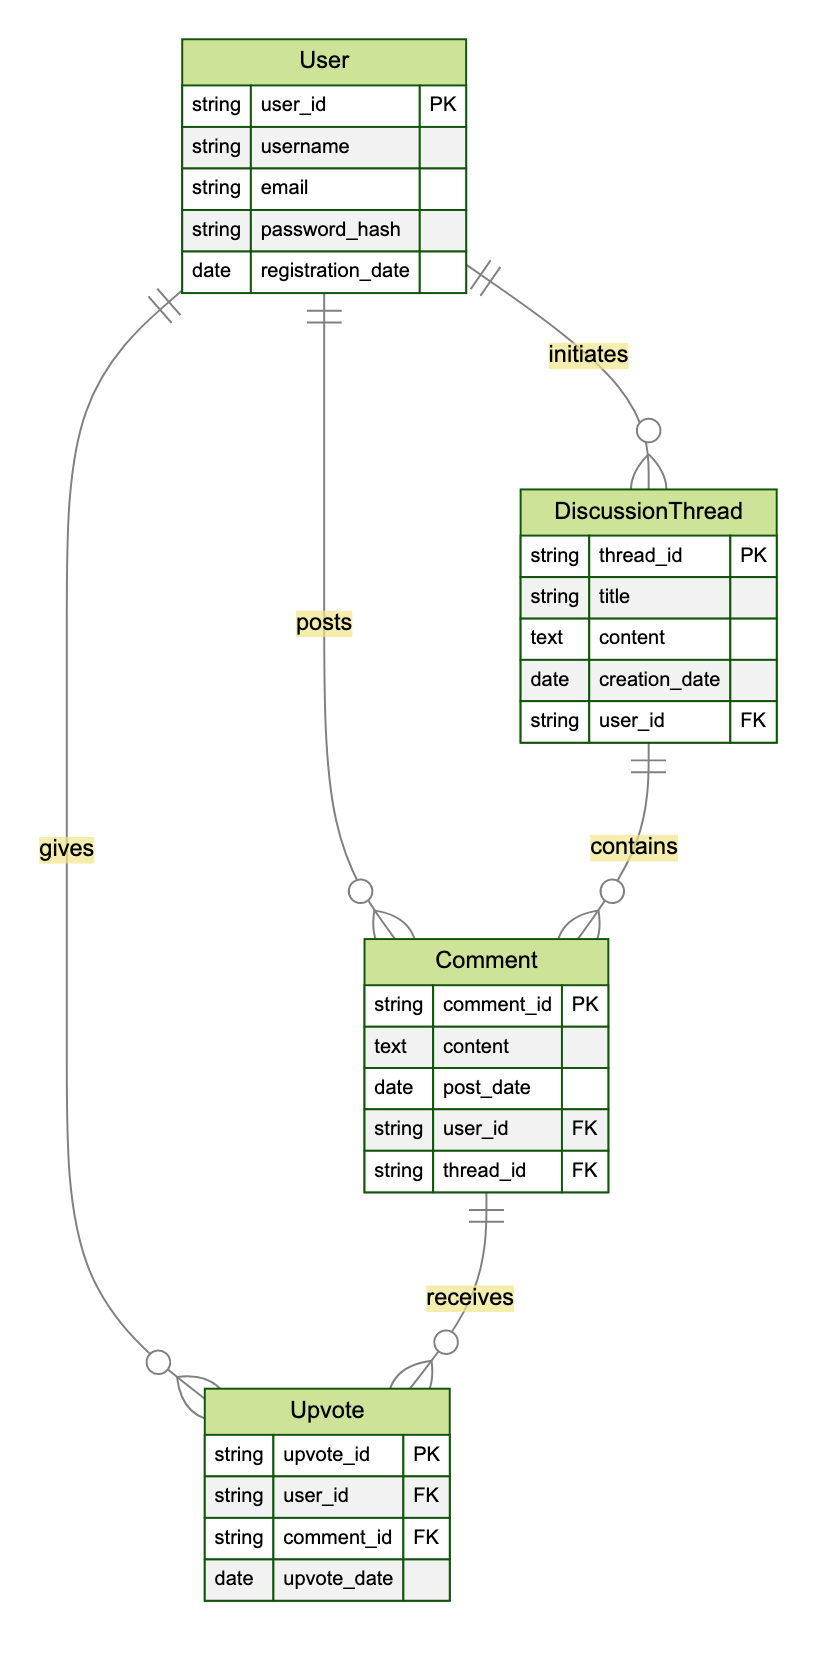What is the primary key for the User entity? The primary key for the User entity is identified as "user_id" in the diagram, indicating that each user has a unique identifier.
Answer: user_id How many entities are there in the diagram? By counting the entities listed in the diagram, we can see there are four distinct entities: User, DiscussionThread, Comment, and Upvote.
Answer: 4 What relationship does a Comment have with Upvote? The relationship is indicated as "receives," which means a comment can receive multiple upvotes from users.
Answer: receives Which entity initiates a DiscussionThread? The description states that a User initiates a DiscussionThread, which establishes that the user has the role of starting the discussion.
Answer: User What is the foreign key in the Comment entity? The foreign keys are indicated for the Comment entity as "user_id" and "thread_id," referring to users and threads respectively.
Answer: user_id, thread_id How many comments are contained within a DiscussionThread? The relationship between DiscussionThread and Comment is labeled as "contains," indicating that a DiscussionThread can contain multiple comments.
Answer: many What does the Upvote entity relate to? The Upvote entity has a relationship indicated as "applied_to" which points to the Comment entity, showing that upvotes are specifically for comments.
Answer: Comment Which entity is started by a User? According to the relationships defined in the diagram, the entity that is started by a User is the DiscussionThread.
Answer: DiscussionThread What attribute indicates the content of a DiscussionThread? The attribute within the DiscussionThread entity that indicates the content is labeled as "content" in the diagram.
Answer: content 